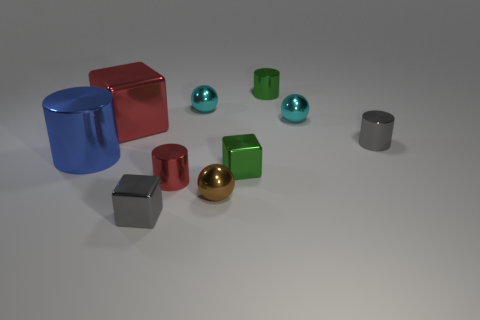Is the number of metallic blocks behind the tiny brown metal object greater than the number of yellow matte balls?
Offer a very short reply. Yes. There is a big blue metallic thing; what shape is it?
Offer a terse response. Cylinder. There is a small metal cube that is on the left side of the tiny brown shiny sphere; is its color the same as the small shiny ball that is in front of the blue shiny cylinder?
Your answer should be compact. No. Does the blue object have the same shape as the brown shiny thing?
Your answer should be very brief. No. Are there any other things that have the same shape as the tiny red metal object?
Your answer should be very brief. Yes. Does the tiny cylinder in front of the big blue thing have the same material as the gray cube?
Give a very brief answer. Yes. The small thing that is to the right of the green cylinder and left of the tiny gray cylinder has what shape?
Make the answer very short. Sphere. Is there a cyan ball behind the tiny green metal thing in front of the red block?
Provide a succinct answer. Yes. What number of other objects are the same material as the small brown sphere?
Keep it short and to the point. 9. Do the green thing that is behind the large red shiny cube and the small gray metallic thing that is in front of the large metal cylinder have the same shape?
Offer a very short reply. No. 